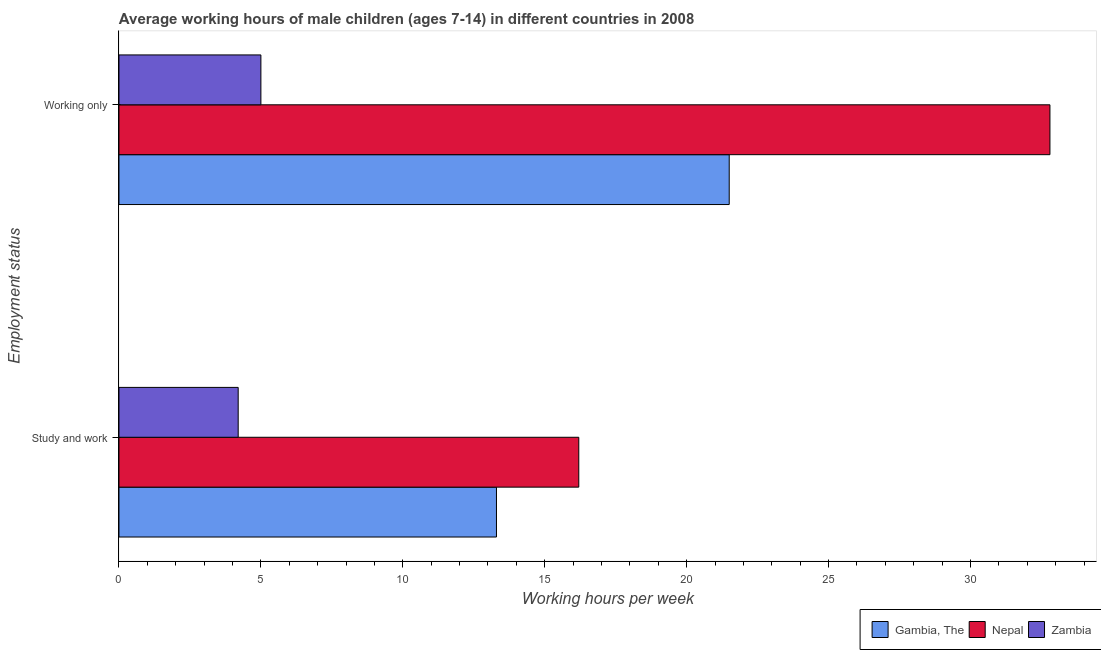How many different coloured bars are there?
Keep it short and to the point. 3. Are the number of bars per tick equal to the number of legend labels?
Provide a succinct answer. Yes. Are the number of bars on each tick of the Y-axis equal?
Ensure brevity in your answer.  Yes. How many bars are there on the 2nd tick from the top?
Provide a short and direct response. 3. What is the label of the 2nd group of bars from the top?
Ensure brevity in your answer.  Study and work. Across all countries, what is the maximum average working hour of children involved in only work?
Offer a terse response. 32.8. Across all countries, what is the minimum average working hour of children involved in only work?
Your answer should be compact. 5. In which country was the average working hour of children involved in only work maximum?
Offer a very short reply. Nepal. In which country was the average working hour of children involved in only work minimum?
Make the answer very short. Zambia. What is the total average working hour of children involved in only work in the graph?
Offer a terse response. 59.3. What is the difference between the average working hour of children involved in only work in Nepal and that in Zambia?
Give a very brief answer. 27.8. What is the average average working hour of children involved in study and work per country?
Your response must be concise. 11.23. What is the difference between the average working hour of children involved in only work and average working hour of children involved in study and work in Zambia?
Offer a terse response. 0.8. What is the ratio of the average working hour of children involved in study and work in Gambia, The to that in Nepal?
Keep it short and to the point. 0.82. Is the average working hour of children involved in study and work in Zambia less than that in Nepal?
Give a very brief answer. Yes. In how many countries, is the average working hour of children involved in only work greater than the average average working hour of children involved in only work taken over all countries?
Make the answer very short. 2. What does the 1st bar from the top in Working only represents?
Offer a very short reply. Zambia. What does the 1st bar from the bottom in Working only represents?
Provide a short and direct response. Gambia, The. How many bars are there?
Keep it short and to the point. 6. How many countries are there in the graph?
Ensure brevity in your answer.  3. What is the difference between two consecutive major ticks on the X-axis?
Ensure brevity in your answer.  5. How many legend labels are there?
Your answer should be compact. 3. How are the legend labels stacked?
Keep it short and to the point. Horizontal. What is the title of the graph?
Ensure brevity in your answer.  Average working hours of male children (ages 7-14) in different countries in 2008. What is the label or title of the X-axis?
Give a very brief answer. Working hours per week. What is the label or title of the Y-axis?
Your answer should be very brief. Employment status. What is the Working hours per week of Nepal in Study and work?
Your response must be concise. 16.2. What is the Working hours per week in Zambia in Study and work?
Keep it short and to the point. 4.2. What is the Working hours per week in Gambia, The in Working only?
Your answer should be compact. 21.5. What is the Working hours per week in Nepal in Working only?
Your response must be concise. 32.8. Across all Employment status, what is the maximum Working hours per week of Nepal?
Your answer should be very brief. 32.8. Across all Employment status, what is the minimum Working hours per week in Gambia, The?
Your answer should be compact. 13.3. Across all Employment status, what is the minimum Working hours per week in Nepal?
Offer a very short reply. 16.2. What is the total Working hours per week of Gambia, The in the graph?
Offer a terse response. 34.8. What is the total Working hours per week of Zambia in the graph?
Your answer should be very brief. 9.2. What is the difference between the Working hours per week of Nepal in Study and work and that in Working only?
Your response must be concise. -16.6. What is the difference between the Working hours per week of Gambia, The in Study and work and the Working hours per week of Nepal in Working only?
Make the answer very short. -19.5. What is the average Working hours per week in Gambia, The per Employment status?
Give a very brief answer. 17.4. What is the average Working hours per week of Nepal per Employment status?
Keep it short and to the point. 24.5. What is the difference between the Working hours per week of Gambia, The and Working hours per week of Zambia in Study and work?
Offer a very short reply. 9.1. What is the difference between the Working hours per week of Nepal and Working hours per week of Zambia in Working only?
Provide a succinct answer. 27.8. What is the ratio of the Working hours per week in Gambia, The in Study and work to that in Working only?
Your response must be concise. 0.62. What is the ratio of the Working hours per week in Nepal in Study and work to that in Working only?
Your response must be concise. 0.49. What is the ratio of the Working hours per week of Zambia in Study and work to that in Working only?
Provide a short and direct response. 0.84. 